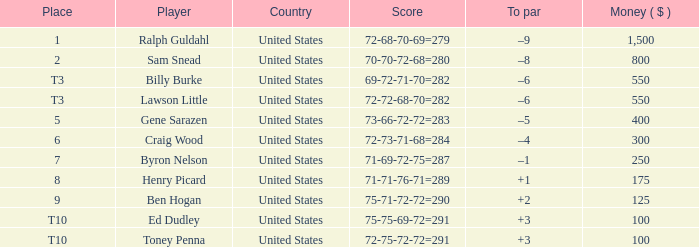Which score has a prize of $400? 73-66-72-72=283. Could you help me parse every detail presented in this table? {'header': ['Place', 'Player', 'Country', 'Score', 'To par', 'Money ( $ )'], 'rows': [['1', 'Ralph Guldahl', 'United States', '72-68-70-69=279', '–9', '1,500'], ['2', 'Sam Snead', 'United States', '70-70-72-68=280', '–8', '800'], ['T3', 'Billy Burke', 'United States', '69-72-71-70=282', '–6', '550'], ['T3', 'Lawson Little', 'United States', '72-72-68-70=282', '–6', '550'], ['5', 'Gene Sarazen', 'United States', '73-66-72-72=283', '–5', '400'], ['6', 'Craig Wood', 'United States', '72-73-71-68=284', '–4', '300'], ['7', 'Byron Nelson', 'United States', '71-69-72-75=287', '–1', '250'], ['8', 'Henry Picard', 'United States', '71-71-76-71=289', '+1', '175'], ['9', 'Ben Hogan', 'United States', '75-71-72-72=290', '+2', '125'], ['T10', 'Ed Dudley', 'United States', '75-75-69-72=291', '+3', '100'], ['T10', 'Toney Penna', 'United States', '72-75-72-72=291', '+3', '100']]} 